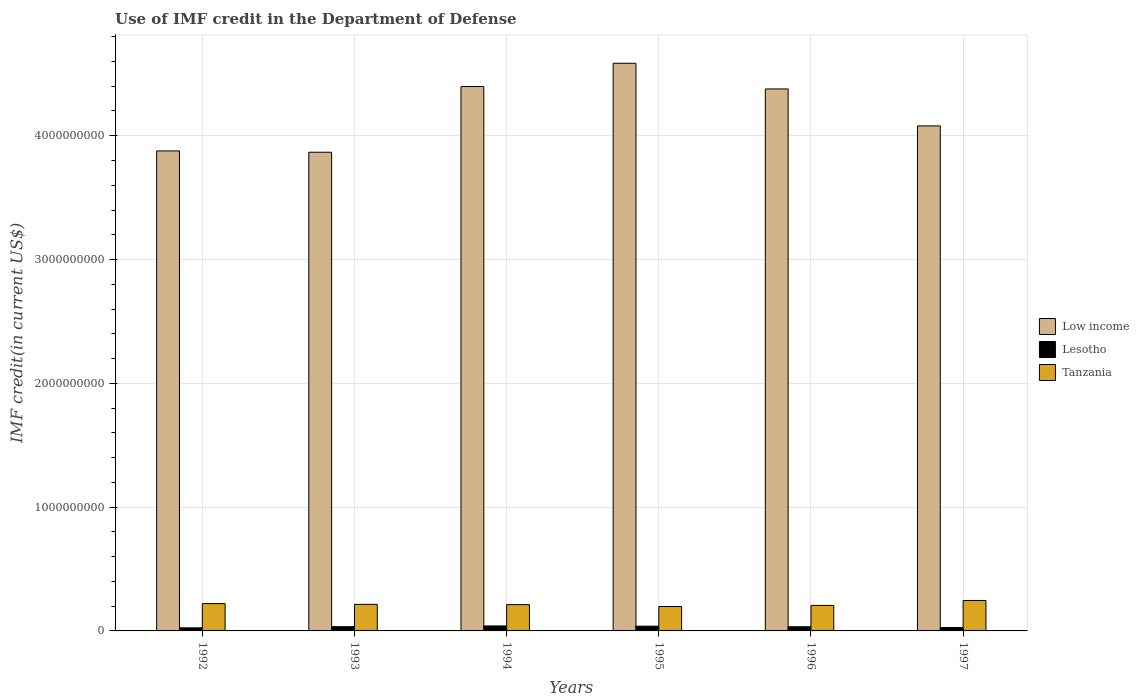How many different coloured bars are there?
Offer a very short reply. 3. Are the number of bars per tick equal to the number of legend labels?
Offer a terse response. Yes. How many bars are there on the 1st tick from the left?
Ensure brevity in your answer.  3. In how many cases, is the number of bars for a given year not equal to the number of legend labels?
Provide a short and direct response. 0. What is the IMF credit in the Department of Defense in Tanzania in 1992?
Ensure brevity in your answer.  2.21e+08. Across all years, what is the maximum IMF credit in the Department of Defense in Lesotho?
Keep it short and to the point. 4.03e+07. Across all years, what is the minimum IMF credit in the Department of Defense in Lesotho?
Provide a short and direct response. 2.49e+07. What is the total IMF credit in the Department of Defense in Low income in the graph?
Your answer should be very brief. 2.52e+1. What is the difference between the IMF credit in the Department of Defense in Tanzania in 1995 and that in 1997?
Provide a succinct answer. -4.88e+07. What is the difference between the IMF credit in the Department of Defense in Low income in 1997 and the IMF credit in the Department of Defense in Tanzania in 1995?
Offer a very short reply. 3.88e+09. What is the average IMF credit in the Department of Defense in Lesotho per year?
Your answer should be compact. 3.32e+07. In the year 1995, what is the difference between the IMF credit in the Department of Defense in Lesotho and IMF credit in the Department of Defense in Low income?
Give a very brief answer. -4.55e+09. What is the ratio of the IMF credit in the Department of Defense in Tanzania in 1992 to that in 1993?
Ensure brevity in your answer.  1.03. What is the difference between the highest and the second highest IMF credit in the Department of Defense in Lesotho?
Offer a terse response. 1.96e+06. What is the difference between the highest and the lowest IMF credit in the Department of Defense in Lesotho?
Offer a very short reply. 1.54e+07. Is the sum of the IMF credit in the Department of Defense in Low income in 1996 and 1997 greater than the maximum IMF credit in the Department of Defense in Lesotho across all years?
Your answer should be very brief. Yes. What does the 3rd bar from the left in 1995 represents?
Give a very brief answer. Tanzania. What does the 2nd bar from the right in 1992 represents?
Offer a terse response. Lesotho. How many bars are there?
Give a very brief answer. 18. Are the values on the major ticks of Y-axis written in scientific E-notation?
Your response must be concise. No. Does the graph contain any zero values?
Keep it short and to the point. No. How many legend labels are there?
Offer a terse response. 3. What is the title of the graph?
Your answer should be compact. Use of IMF credit in the Department of Defense. What is the label or title of the X-axis?
Give a very brief answer. Years. What is the label or title of the Y-axis?
Your answer should be very brief. IMF credit(in current US$). What is the IMF credit(in current US$) in Low income in 1992?
Provide a succinct answer. 3.88e+09. What is the IMF credit(in current US$) in Lesotho in 1992?
Give a very brief answer. 2.49e+07. What is the IMF credit(in current US$) in Tanzania in 1992?
Give a very brief answer. 2.21e+08. What is the IMF credit(in current US$) of Low income in 1993?
Your answer should be compact. 3.87e+09. What is the IMF credit(in current US$) in Lesotho in 1993?
Offer a very short reply. 3.42e+07. What is the IMF credit(in current US$) in Tanzania in 1993?
Keep it short and to the point. 2.15e+08. What is the IMF credit(in current US$) of Low income in 1994?
Provide a short and direct response. 4.40e+09. What is the IMF credit(in current US$) in Lesotho in 1994?
Offer a terse response. 4.03e+07. What is the IMF credit(in current US$) of Tanzania in 1994?
Give a very brief answer. 2.12e+08. What is the IMF credit(in current US$) in Low income in 1995?
Make the answer very short. 4.59e+09. What is the IMF credit(in current US$) of Lesotho in 1995?
Give a very brief answer. 3.84e+07. What is the IMF credit(in current US$) in Tanzania in 1995?
Offer a very short reply. 1.97e+08. What is the IMF credit(in current US$) in Low income in 1996?
Ensure brevity in your answer.  4.38e+09. What is the IMF credit(in current US$) in Lesotho in 1996?
Ensure brevity in your answer.  3.38e+07. What is the IMF credit(in current US$) of Tanzania in 1996?
Provide a short and direct response. 2.06e+08. What is the IMF credit(in current US$) in Low income in 1997?
Keep it short and to the point. 4.08e+09. What is the IMF credit(in current US$) of Lesotho in 1997?
Make the answer very short. 2.75e+07. What is the IMF credit(in current US$) of Tanzania in 1997?
Your answer should be very brief. 2.46e+08. Across all years, what is the maximum IMF credit(in current US$) in Low income?
Keep it short and to the point. 4.59e+09. Across all years, what is the maximum IMF credit(in current US$) in Lesotho?
Your answer should be compact. 4.03e+07. Across all years, what is the maximum IMF credit(in current US$) in Tanzania?
Provide a short and direct response. 2.46e+08. Across all years, what is the minimum IMF credit(in current US$) in Low income?
Provide a short and direct response. 3.87e+09. Across all years, what is the minimum IMF credit(in current US$) of Lesotho?
Make the answer very short. 2.49e+07. Across all years, what is the minimum IMF credit(in current US$) in Tanzania?
Make the answer very short. 1.97e+08. What is the total IMF credit(in current US$) in Low income in the graph?
Your response must be concise. 2.52e+1. What is the total IMF credit(in current US$) in Lesotho in the graph?
Provide a short and direct response. 1.99e+08. What is the total IMF credit(in current US$) in Tanzania in the graph?
Ensure brevity in your answer.  1.30e+09. What is the difference between the IMF credit(in current US$) in Low income in 1992 and that in 1993?
Keep it short and to the point. 1.07e+07. What is the difference between the IMF credit(in current US$) in Lesotho in 1992 and that in 1993?
Offer a very short reply. -9.31e+06. What is the difference between the IMF credit(in current US$) in Tanzania in 1992 and that in 1993?
Make the answer very short. 6.11e+06. What is the difference between the IMF credit(in current US$) in Low income in 1992 and that in 1994?
Your answer should be compact. -5.20e+08. What is the difference between the IMF credit(in current US$) in Lesotho in 1992 and that in 1994?
Your response must be concise. -1.54e+07. What is the difference between the IMF credit(in current US$) of Tanzania in 1992 and that in 1994?
Your response must be concise. 8.25e+06. What is the difference between the IMF credit(in current US$) in Low income in 1992 and that in 1995?
Ensure brevity in your answer.  -7.08e+08. What is the difference between the IMF credit(in current US$) of Lesotho in 1992 and that in 1995?
Give a very brief answer. -1.35e+07. What is the difference between the IMF credit(in current US$) in Tanzania in 1992 and that in 1995?
Keep it short and to the point. 2.35e+07. What is the difference between the IMF credit(in current US$) in Low income in 1992 and that in 1996?
Give a very brief answer. -5.01e+08. What is the difference between the IMF credit(in current US$) of Lesotho in 1992 and that in 1996?
Ensure brevity in your answer.  -8.85e+06. What is the difference between the IMF credit(in current US$) in Tanzania in 1992 and that in 1996?
Provide a short and direct response. 1.45e+07. What is the difference between the IMF credit(in current US$) of Low income in 1992 and that in 1997?
Make the answer very short. -2.02e+08. What is the difference between the IMF credit(in current US$) in Lesotho in 1992 and that in 1997?
Provide a succinct answer. -2.59e+06. What is the difference between the IMF credit(in current US$) in Tanzania in 1992 and that in 1997?
Offer a terse response. -2.54e+07. What is the difference between the IMF credit(in current US$) in Low income in 1993 and that in 1994?
Provide a succinct answer. -5.31e+08. What is the difference between the IMF credit(in current US$) of Lesotho in 1993 and that in 1994?
Offer a very short reply. -6.12e+06. What is the difference between the IMF credit(in current US$) in Tanzania in 1993 and that in 1994?
Your answer should be very brief. 2.14e+06. What is the difference between the IMF credit(in current US$) of Low income in 1993 and that in 1995?
Offer a terse response. -7.19e+08. What is the difference between the IMF credit(in current US$) in Lesotho in 1993 and that in 1995?
Provide a short and direct response. -4.16e+06. What is the difference between the IMF credit(in current US$) in Tanzania in 1993 and that in 1995?
Make the answer very short. 1.74e+07. What is the difference between the IMF credit(in current US$) of Low income in 1993 and that in 1996?
Offer a very short reply. -5.11e+08. What is the difference between the IMF credit(in current US$) of Lesotho in 1993 and that in 1996?
Provide a short and direct response. 4.57e+05. What is the difference between the IMF credit(in current US$) of Tanzania in 1993 and that in 1996?
Give a very brief answer. 8.36e+06. What is the difference between the IMF credit(in current US$) of Low income in 1993 and that in 1997?
Keep it short and to the point. -2.13e+08. What is the difference between the IMF credit(in current US$) in Lesotho in 1993 and that in 1997?
Your answer should be very brief. 6.72e+06. What is the difference between the IMF credit(in current US$) in Tanzania in 1993 and that in 1997?
Offer a terse response. -3.15e+07. What is the difference between the IMF credit(in current US$) in Low income in 1994 and that in 1995?
Ensure brevity in your answer.  -1.88e+08. What is the difference between the IMF credit(in current US$) in Lesotho in 1994 and that in 1995?
Your answer should be compact. 1.96e+06. What is the difference between the IMF credit(in current US$) in Tanzania in 1994 and that in 1995?
Provide a short and direct response. 1.52e+07. What is the difference between the IMF credit(in current US$) in Low income in 1994 and that in 1996?
Your answer should be very brief. 1.94e+07. What is the difference between the IMF credit(in current US$) of Lesotho in 1994 and that in 1996?
Provide a short and direct response. 6.58e+06. What is the difference between the IMF credit(in current US$) in Tanzania in 1994 and that in 1996?
Give a very brief answer. 6.22e+06. What is the difference between the IMF credit(in current US$) of Low income in 1994 and that in 1997?
Offer a terse response. 3.18e+08. What is the difference between the IMF credit(in current US$) in Lesotho in 1994 and that in 1997?
Your answer should be compact. 1.28e+07. What is the difference between the IMF credit(in current US$) of Tanzania in 1994 and that in 1997?
Provide a short and direct response. -3.36e+07. What is the difference between the IMF credit(in current US$) of Low income in 1995 and that in 1996?
Your answer should be compact. 2.07e+08. What is the difference between the IMF credit(in current US$) in Lesotho in 1995 and that in 1996?
Provide a succinct answer. 4.62e+06. What is the difference between the IMF credit(in current US$) of Tanzania in 1995 and that in 1996?
Your answer should be compact. -8.99e+06. What is the difference between the IMF credit(in current US$) in Low income in 1995 and that in 1997?
Your response must be concise. 5.06e+08. What is the difference between the IMF credit(in current US$) of Lesotho in 1995 and that in 1997?
Offer a very short reply. 1.09e+07. What is the difference between the IMF credit(in current US$) of Tanzania in 1995 and that in 1997?
Make the answer very short. -4.88e+07. What is the difference between the IMF credit(in current US$) of Low income in 1996 and that in 1997?
Your answer should be compact. 2.99e+08. What is the difference between the IMF credit(in current US$) in Lesotho in 1996 and that in 1997?
Your answer should be compact. 6.26e+06. What is the difference between the IMF credit(in current US$) in Tanzania in 1996 and that in 1997?
Provide a short and direct response. -3.98e+07. What is the difference between the IMF credit(in current US$) of Low income in 1992 and the IMF credit(in current US$) of Lesotho in 1993?
Ensure brevity in your answer.  3.84e+09. What is the difference between the IMF credit(in current US$) in Low income in 1992 and the IMF credit(in current US$) in Tanzania in 1993?
Your answer should be compact. 3.66e+09. What is the difference between the IMF credit(in current US$) in Lesotho in 1992 and the IMF credit(in current US$) in Tanzania in 1993?
Your response must be concise. -1.90e+08. What is the difference between the IMF credit(in current US$) in Low income in 1992 and the IMF credit(in current US$) in Lesotho in 1994?
Provide a succinct answer. 3.84e+09. What is the difference between the IMF credit(in current US$) in Low income in 1992 and the IMF credit(in current US$) in Tanzania in 1994?
Provide a succinct answer. 3.66e+09. What is the difference between the IMF credit(in current US$) of Lesotho in 1992 and the IMF credit(in current US$) of Tanzania in 1994?
Your answer should be compact. -1.88e+08. What is the difference between the IMF credit(in current US$) in Low income in 1992 and the IMF credit(in current US$) in Lesotho in 1995?
Keep it short and to the point. 3.84e+09. What is the difference between the IMF credit(in current US$) of Low income in 1992 and the IMF credit(in current US$) of Tanzania in 1995?
Your answer should be compact. 3.68e+09. What is the difference between the IMF credit(in current US$) of Lesotho in 1992 and the IMF credit(in current US$) of Tanzania in 1995?
Ensure brevity in your answer.  -1.72e+08. What is the difference between the IMF credit(in current US$) in Low income in 1992 and the IMF credit(in current US$) in Lesotho in 1996?
Offer a very short reply. 3.84e+09. What is the difference between the IMF credit(in current US$) in Low income in 1992 and the IMF credit(in current US$) in Tanzania in 1996?
Your answer should be very brief. 3.67e+09. What is the difference between the IMF credit(in current US$) of Lesotho in 1992 and the IMF credit(in current US$) of Tanzania in 1996?
Make the answer very short. -1.81e+08. What is the difference between the IMF credit(in current US$) of Low income in 1992 and the IMF credit(in current US$) of Lesotho in 1997?
Provide a short and direct response. 3.85e+09. What is the difference between the IMF credit(in current US$) of Low income in 1992 and the IMF credit(in current US$) of Tanzania in 1997?
Your response must be concise. 3.63e+09. What is the difference between the IMF credit(in current US$) in Lesotho in 1992 and the IMF credit(in current US$) in Tanzania in 1997?
Offer a terse response. -2.21e+08. What is the difference between the IMF credit(in current US$) of Low income in 1993 and the IMF credit(in current US$) of Lesotho in 1994?
Ensure brevity in your answer.  3.83e+09. What is the difference between the IMF credit(in current US$) of Low income in 1993 and the IMF credit(in current US$) of Tanzania in 1994?
Give a very brief answer. 3.65e+09. What is the difference between the IMF credit(in current US$) in Lesotho in 1993 and the IMF credit(in current US$) in Tanzania in 1994?
Offer a very short reply. -1.78e+08. What is the difference between the IMF credit(in current US$) of Low income in 1993 and the IMF credit(in current US$) of Lesotho in 1995?
Make the answer very short. 3.83e+09. What is the difference between the IMF credit(in current US$) in Low income in 1993 and the IMF credit(in current US$) in Tanzania in 1995?
Your answer should be compact. 3.67e+09. What is the difference between the IMF credit(in current US$) in Lesotho in 1993 and the IMF credit(in current US$) in Tanzania in 1995?
Your answer should be compact. -1.63e+08. What is the difference between the IMF credit(in current US$) in Low income in 1993 and the IMF credit(in current US$) in Lesotho in 1996?
Offer a terse response. 3.83e+09. What is the difference between the IMF credit(in current US$) of Low income in 1993 and the IMF credit(in current US$) of Tanzania in 1996?
Ensure brevity in your answer.  3.66e+09. What is the difference between the IMF credit(in current US$) in Lesotho in 1993 and the IMF credit(in current US$) in Tanzania in 1996?
Ensure brevity in your answer.  -1.72e+08. What is the difference between the IMF credit(in current US$) in Low income in 1993 and the IMF credit(in current US$) in Lesotho in 1997?
Your answer should be compact. 3.84e+09. What is the difference between the IMF credit(in current US$) of Low income in 1993 and the IMF credit(in current US$) of Tanzania in 1997?
Ensure brevity in your answer.  3.62e+09. What is the difference between the IMF credit(in current US$) of Lesotho in 1993 and the IMF credit(in current US$) of Tanzania in 1997?
Offer a very short reply. -2.12e+08. What is the difference between the IMF credit(in current US$) in Low income in 1994 and the IMF credit(in current US$) in Lesotho in 1995?
Your answer should be very brief. 4.36e+09. What is the difference between the IMF credit(in current US$) of Low income in 1994 and the IMF credit(in current US$) of Tanzania in 1995?
Offer a very short reply. 4.20e+09. What is the difference between the IMF credit(in current US$) in Lesotho in 1994 and the IMF credit(in current US$) in Tanzania in 1995?
Your response must be concise. -1.57e+08. What is the difference between the IMF credit(in current US$) in Low income in 1994 and the IMF credit(in current US$) in Lesotho in 1996?
Your response must be concise. 4.36e+09. What is the difference between the IMF credit(in current US$) of Low income in 1994 and the IMF credit(in current US$) of Tanzania in 1996?
Offer a terse response. 4.19e+09. What is the difference between the IMF credit(in current US$) in Lesotho in 1994 and the IMF credit(in current US$) in Tanzania in 1996?
Make the answer very short. -1.66e+08. What is the difference between the IMF credit(in current US$) of Low income in 1994 and the IMF credit(in current US$) of Lesotho in 1997?
Keep it short and to the point. 4.37e+09. What is the difference between the IMF credit(in current US$) of Low income in 1994 and the IMF credit(in current US$) of Tanzania in 1997?
Keep it short and to the point. 4.15e+09. What is the difference between the IMF credit(in current US$) of Lesotho in 1994 and the IMF credit(in current US$) of Tanzania in 1997?
Offer a very short reply. -2.06e+08. What is the difference between the IMF credit(in current US$) in Low income in 1995 and the IMF credit(in current US$) in Lesotho in 1996?
Your answer should be compact. 4.55e+09. What is the difference between the IMF credit(in current US$) of Low income in 1995 and the IMF credit(in current US$) of Tanzania in 1996?
Your response must be concise. 4.38e+09. What is the difference between the IMF credit(in current US$) in Lesotho in 1995 and the IMF credit(in current US$) in Tanzania in 1996?
Your response must be concise. -1.68e+08. What is the difference between the IMF credit(in current US$) of Low income in 1995 and the IMF credit(in current US$) of Lesotho in 1997?
Make the answer very short. 4.56e+09. What is the difference between the IMF credit(in current US$) in Low income in 1995 and the IMF credit(in current US$) in Tanzania in 1997?
Your response must be concise. 4.34e+09. What is the difference between the IMF credit(in current US$) of Lesotho in 1995 and the IMF credit(in current US$) of Tanzania in 1997?
Provide a short and direct response. -2.08e+08. What is the difference between the IMF credit(in current US$) in Low income in 1996 and the IMF credit(in current US$) in Lesotho in 1997?
Provide a succinct answer. 4.35e+09. What is the difference between the IMF credit(in current US$) in Low income in 1996 and the IMF credit(in current US$) in Tanzania in 1997?
Your answer should be very brief. 4.13e+09. What is the difference between the IMF credit(in current US$) in Lesotho in 1996 and the IMF credit(in current US$) in Tanzania in 1997?
Give a very brief answer. -2.12e+08. What is the average IMF credit(in current US$) of Low income per year?
Give a very brief answer. 4.20e+09. What is the average IMF credit(in current US$) of Lesotho per year?
Provide a succinct answer. 3.32e+07. What is the average IMF credit(in current US$) of Tanzania per year?
Provide a succinct answer. 2.16e+08. In the year 1992, what is the difference between the IMF credit(in current US$) of Low income and IMF credit(in current US$) of Lesotho?
Your answer should be compact. 3.85e+09. In the year 1992, what is the difference between the IMF credit(in current US$) of Low income and IMF credit(in current US$) of Tanzania?
Keep it short and to the point. 3.66e+09. In the year 1992, what is the difference between the IMF credit(in current US$) of Lesotho and IMF credit(in current US$) of Tanzania?
Offer a very short reply. -1.96e+08. In the year 1993, what is the difference between the IMF credit(in current US$) in Low income and IMF credit(in current US$) in Lesotho?
Provide a short and direct response. 3.83e+09. In the year 1993, what is the difference between the IMF credit(in current US$) of Low income and IMF credit(in current US$) of Tanzania?
Keep it short and to the point. 3.65e+09. In the year 1993, what is the difference between the IMF credit(in current US$) in Lesotho and IMF credit(in current US$) in Tanzania?
Offer a very short reply. -1.80e+08. In the year 1994, what is the difference between the IMF credit(in current US$) of Low income and IMF credit(in current US$) of Lesotho?
Provide a succinct answer. 4.36e+09. In the year 1994, what is the difference between the IMF credit(in current US$) of Low income and IMF credit(in current US$) of Tanzania?
Offer a very short reply. 4.18e+09. In the year 1994, what is the difference between the IMF credit(in current US$) in Lesotho and IMF credit(in current US$) in Tanzania?
Your answer should be compact. -1.72e+08. In the year 1995, what is the difference between the IMF credit(in current US$) in Low income and IMF credit(in current US$) in Lesotho?
Provide a short and direct response. 4.55e+09. In the year 1995, what is the difference between the IMF credit(in current US$) of Low income and IMF credit(in current US$) of Tanzania?
Provide a short and direct response. 4.39e+09. In the year 1995, what is the difference between the IMF credit(in current US$) of Lesotho and IMF credit(in current US$) of Tanzania?
Make the answer very short. -1.59e+08. In the year 1996, what is the difference between the IMF credit(in current US$) of Low income and IMF credit(in current US$) of Lesotho?
Keep it short and to the point. 4.34e+09. In the year 1996, what is the difference between the IMF credit(in current US$) in Low income and IMF credit(in current US$) in Tanzania?
Give a very brief answer. 4.17e+09. In the year 1996, what is the difference between the IMF credit(in current US$) of Lesotho and IMF credit(in current US$) of Tanzania?
Your answer should be compact. -1.72e+08. In the year 1997, what is the difference between the IMF credit(in current US$) of Low income and IMF credit(in current US$) of Lesotho?
Ensure brevity in your answer.  4.05e+09. In the year 1997, what is the difference between the IMF credit(in current US$) in Low income and IMF credit(in current US$) in Tanzania?
Offer a very short reply. 3.83e+09. In the year 1997, what is the difference between the IMF credit(in current US$) of Lesotho and IMF credit(in current US$) of Tanzania?
Ensure brevity in your answer.  -2.19e+08. What is the ratio of the IMF credit(in current US$) of Low income in 1992 to that in 1993?
Your response must be concise. 1. What is the ratio of the IMF credit(in current US$) of Lesotho in 1992 to that in 1993?
Your answer should be compact. 0.73. What is the ratio of the IMF credit(in current US$) in Tanzania in 1992 to that in 1993?
Keep it short and to the point. 1.03. What is the ratio of the IMF credit(in current US$) of Low income in 1992 to that in 1994?
Your answer should be very brief. 0.88. What is the ratio of the IMF credit(in current US$) in Lesotho in 1992 to that in 1994?
Your answer should be very brief. 0.62. What is the ratio of the IMF credit(in current US$) in Tanzania in 1992 to that in 1994?
Your answer should be compact. 1.04. What is the ratio of the IMF credit(in current US$) in Low income in 1992 to that in 1995?
Offer a very short reply. 0.85. What is the ratio of the IMF credit(in current US$) in Lesotho in 1992 to that in 1995?
Your answer should be compact. 0.65. What is the ratio of the IMF credit(in current US$) of Tanzania in 1992 to that in 1995?
Your answer should be very brief. 1.12. What is the ratio of the IMF credit(in current US$) of Low income in 1992 to that in 1996?
Keep it short and to the point. 0.89. What is the ratio of the IMF credit(in current US$) in Lesotho in 1992 to that in 1996?
Your response must be concise. 0.74. What is the ratio of the IMF credit(in current US$) in Tanzania in 1992 to that in 1996?
Keep it short and to the point. 1.07. What is the ratio of the IMF credit(in current US$) in Low income in 1992 to that in 1997?
Provide a succinct answer. 0.95. What is the ratio of the IMF credit(in current US$) in Lesotho in 1992 to that in 1997?
Offer a terse response. 0.91. What is the ratio of the IMF credit(in current US$) in Tanzania in 1992 to that in 1997?
Your answer should be compact. 0.9. What is the ratio of the IMF credit(in current US$) of Low income in 1993 to that in 1994?
Provide a short and direct response. 0.88. What is the ratio of the IMF credit(in current US$) in Lesotho in 1993 to that in 1994?
Your answer should be compact. 0.85. What is the ratio of the IMF credit(in current US$) in Low income in 1993 to that in 1995?
Your response must be concise. 0.84. What is the ratio of the IMF credit(in current US$) of Lesotho in 1993 to that in 1995?
Your answer should be compact. 0.89. What is the ratio of the IMF credit(in current US$) of Tanzania in 1993 to that in 1995?
Provide a succinct answer. 1.09. What is the ratio of the IMF credit(in current US$) of Low income in 1993 to that in 1996?
Offer a very short reply. 0.88. What is the ratio of the IMF credit(in current US$) in Lesotho in 1993 to that in 1996?
Your answer should be very brief. 1.01. What is the ratio of the IMF credit(in current US$) in Tanzania in 1993 to that in 1996?
Keep it short and to the point. 1.04. What is the ratio of the IMF credit(in current US$) of Low income in 1993 to that in 1997?
Provide a succinct answer. 0.95. What is the ratio of the IMF credit(in current US$) in Lesotho in 1993 to that in 1997?
Your answer should be compact. 1.24. What is the ratio of the IMF credit(in current US$) in Tanzania in 1993 to that in 1997?
Give a very brief answer. 0.87. What is the ratio of the IMF credit(in current US$) in Lesotho in 1994 to that in 1995?
Offer a very short reply. 1.05. What is the ratio of the IMF credit(in current US$) of Tanzania in 1994 to that in 1995?
Keep it short and to the point. 1.08. What is the ratio of the IMF credit(in current US$) in Low income in 1994 to that in 1996?
Your answer should be compact. 1. What is the ratio of the IMF credit(in current US$) in Lesotho in 1994 to that in 1996?
Your answer should be compact. 1.19. What is the ratio of the IMF credit(in current US$) in Tanzania in 1994 to that in 1996?
Keep it short and to the point. 1.03. What is the ratio of the IMF credit(in current US$) of Low income in 1994 to that in 1997?
Your answer should be compact. 1.08. What is the ratio of the IMF credit(in current US$) of Lesotho in 1994 to that in 1997?
Give a very brief answer. 1.47. What is the ratio of the IMF credit(in current US$) of Tanzania in 1994 to that in 1997?
Your answer should be compact. 0.86. What is the ratio of the IMF credit(in current US$) of Low income in 1995 to that in 1996?
Your response must be concise. 1.05. What is the ratio of the IMF credit(in current US$) of Lesotho in 1995 to that in 1996?
Keep it short and to the point. 1.14. What is the ratio of the IMF credit(in current US$) in Tanzania in 1995 to that in 1996?
Provide a succinct answer. 0.96. What is the ratio of the IMF credit(in current US$) in Low income in 1995 to that in 1997?
Your answer should be compact. 1.12. What is the ratio of the IMF credit(in current US$) in Lesotho in 1995 to that in 1997?
Keep it short and to the point. 1.4. What is the ratio of the IMF credit(in current US$) in Tanzania in 1995 to that in 1997?
Keep it short and to the point. 0.8. What is the ratio of the IMF credit(in current US$) in Low income in 1996 to that in 1997?
Keep it short and to the point. 1.07. What is the ratio of the IMF credit(in current US$) in Lesotho in 1996 to that in 1997?
Provide a succinct answer. 1.23. What is the ratio of the IMF credit(in current US$) of Tanzania in 1996 to that in 1997?
Make the answer very short. 0.84. What is the difference between the highest and the second highest IMF credit(in current US$) of Low income?
Offer a very short reply. 1.88e+08. What is the difference between the highest and the second highest IMF credit(in current US$) in Lesotho?
Give a very brief answer. 1.96e+06. What is the difference between the highest and the second highest IMF credit(in current US$) in Tanzania?
Your response must be concise. 2.54e+07. What is the difference between the highest and the lowest IMF credit(in current US$) in Low income?
Your answer should be very brief. 7.19e+08. What is the difference between the highest and the lowest IMF credit(in current US$) in Lesotho?
Give a very brief answer. 1.54e+07. What is the difference between the highest and the lowest IMF credit(in current US$) in Tanzania?
Provide a short and direct response. 4.88e+07. 